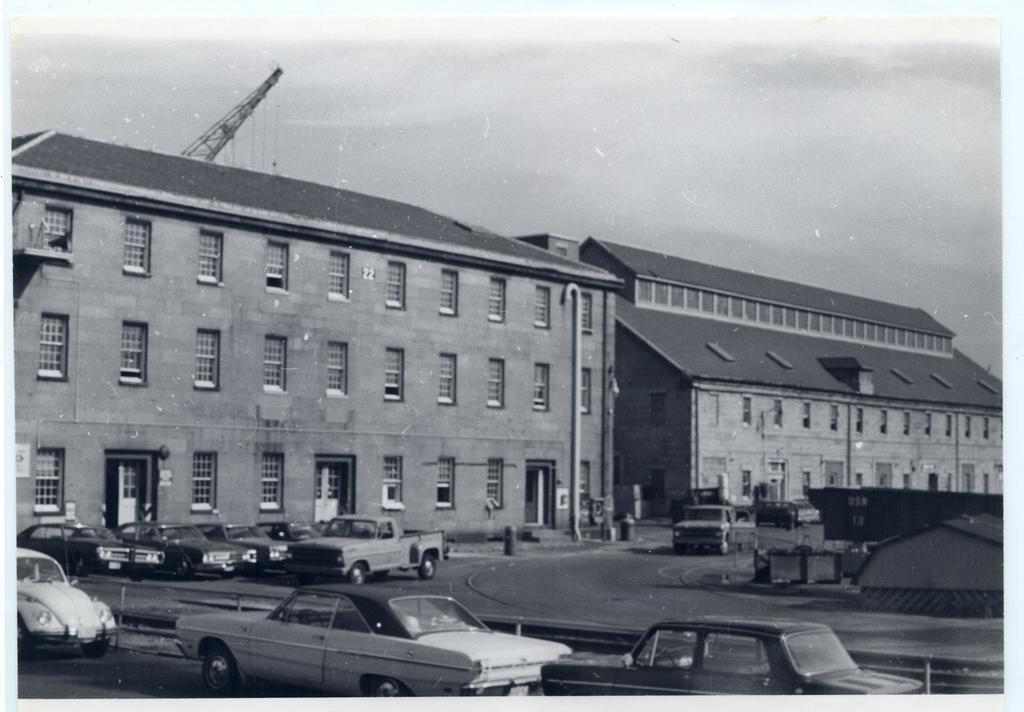How would you summarize this image in a sentence or two? This is a black and white image. We can see some buildings. We can see the ground with some objects. There are a few vehicles. We can see some poles. We can also see a tower and the sky. 